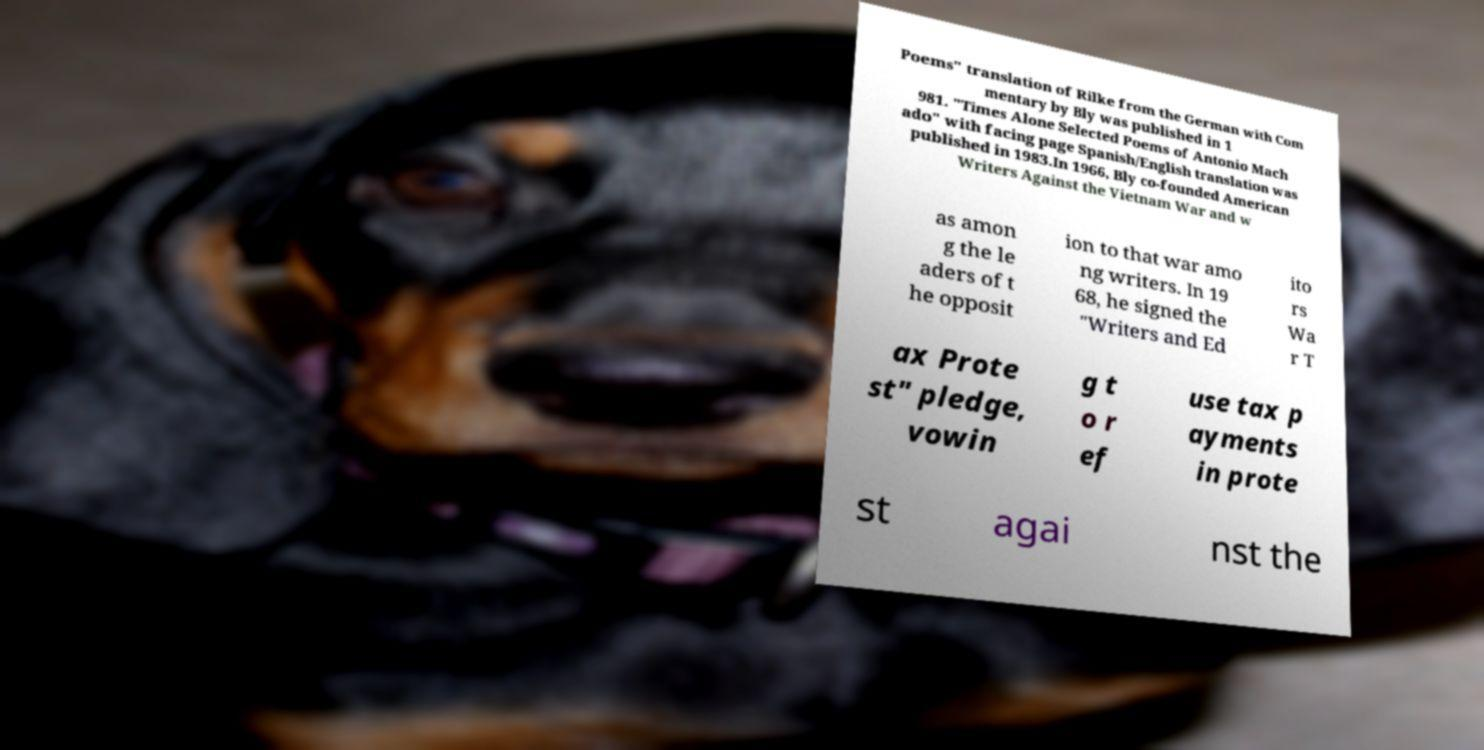I need the written content from this picture converted into text. Can you do that? Poems" translation of Rilke from the German with Com mentary by Bly was published in 1 981. "Times Alone Selected Poems of Antonio Mach ado" with facing page Spanish/English translation was published in 1983.In 1966, Bly co-founded American Writers Against the Vietnam War and w as amon g the le aders of t he opposit ion to that war amo ng writers. In 19 68, he signed the "Writers and Ed ito rs Wa r T ax Prote st" pledge, vowin g t o r ef use tax p ayments in prote st agai nst the 